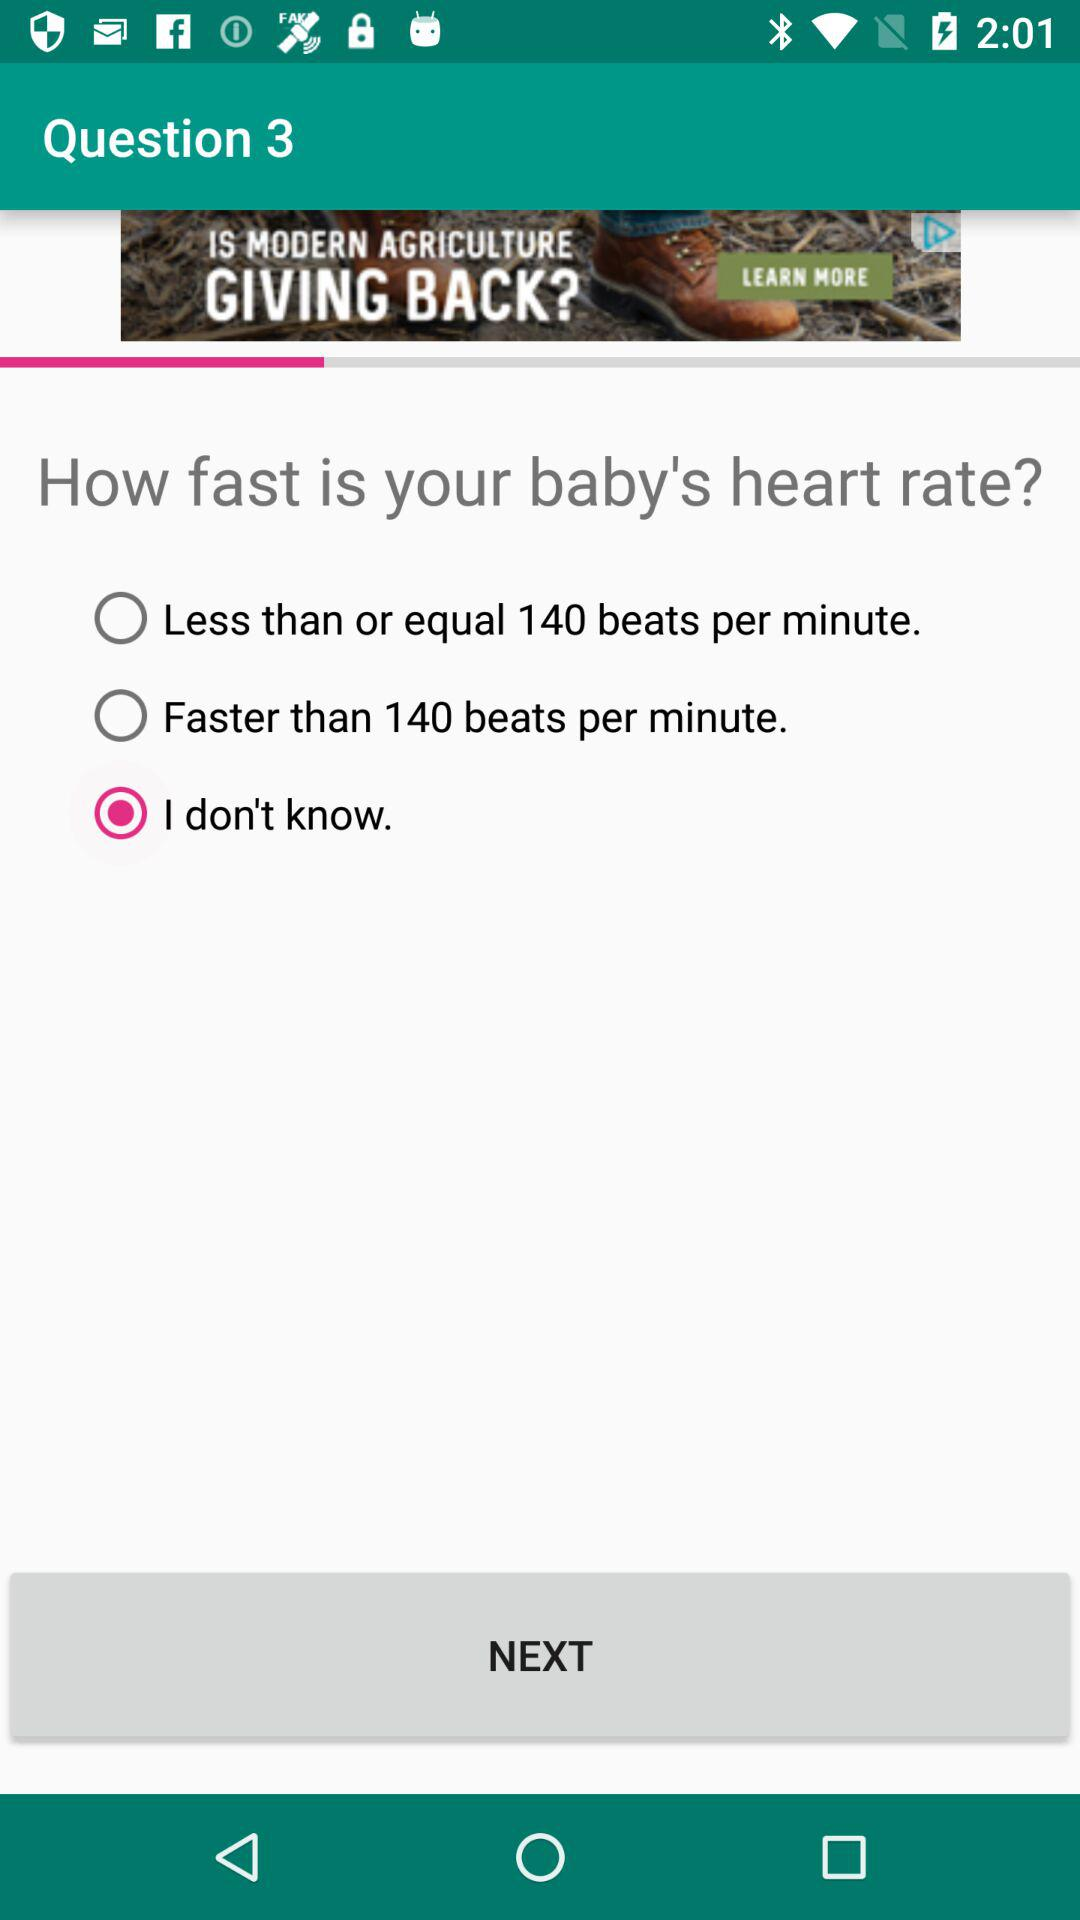How many options are there to select the baby's heart rate?
Answer the question using a single word or phrase. 3 